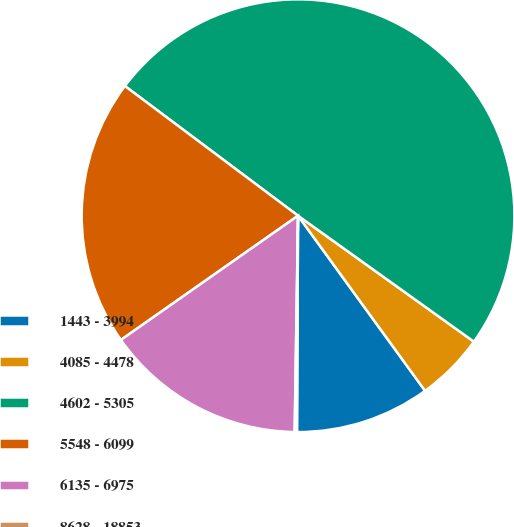Convert chart. <chart><loc_0><loc_0><loc_500><loc_500><pie_chart><fcel>1443 - 3994<fcel>4085 - 4478<fcel>4602 - 5305<fcel>5548 - 6099<fcel>6135 - 6975<fcel>8628 - 18853<nl><fcel>10.07%<fcel>5.12%<fcel>49.67%<fcel>19.97%<fcel>15.02%<fcel>0.17%<nl></chart> 